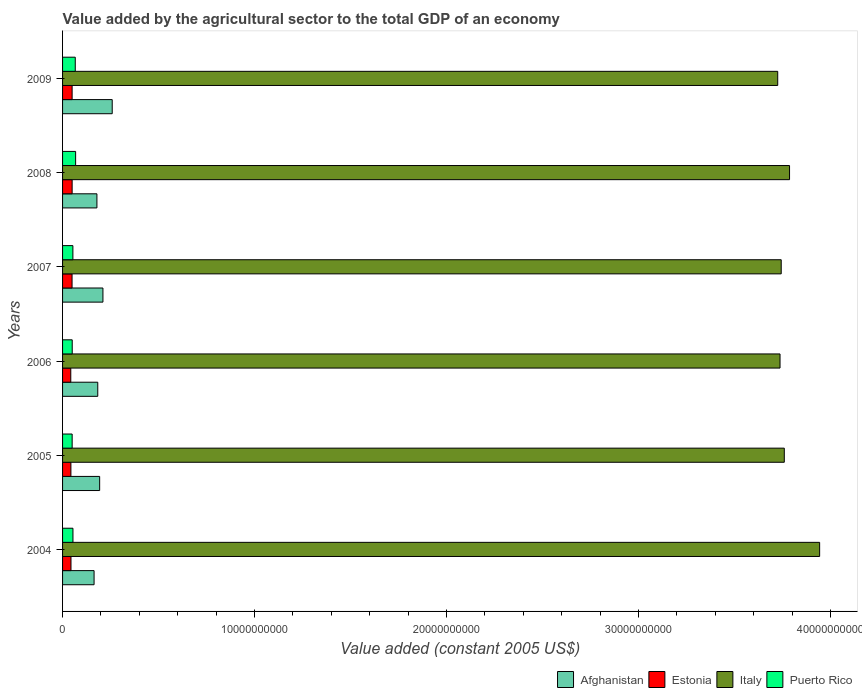How many different coloured bars are there?
Make the answer very short. 4. How many bars are there on the 2nd tick from the bottom?
Your answer should be very brief. 4. In how many cases, is the number of bars for a given year not equal to the number of legend labels?
Provide a succinct answer. 0. What is the value added by the agricultural sector in Afghanistan in 2008?
Keep it short and to the point. 1.79e+09. Across all years, what is the maximum value added by the agricultural sector in Afghanistan?
Ensure brevity in your answer.  2.59e+09. Across all years, what is the minimum value added by the agricultural sector in Afghanistan?
Offer a terse response. 1.64e+09. In which year was the value added by the agricultural sector in Afghanistan maximum?
Keep it short and to the point. 2009. What is the total value added by the agricultural sector in Puerto Rico in the graph?
Provide a succinct answer. 3.42e+09. What is the difference between the value added by the agricultural sector in Puerto Rico in 2008 and that in 2009?
Give a very brief answer. 1.86e+07. What is the difference between the value added by the agricultural sector in Italy in 2004 and the value added by the agricultural sector in Afghanistan in 2009?
Your answer should be compact. 3.68e+1. What is the average value added by the agricultural sector in Italy per year?
Offer a very short reply. 3.78e+1. In the year 2007, what is the difference between the value added by the agricultural sector in Puerto Rico and value added by the agricultural sector in Italy?
Make the answer very short. -3.69e+1. What is the ratio of the value added by the agricultural sector in Italy in 2007 to that in 2009?
Your answer should be very brief. 1. Is the value added by the agricultural sector in Estonia in 2007 less than that in 2009?
Offer a very short reply. Yes. Is the difference between the value added by the agricultural sector in Puerto Rico in 2005 and 2009 greater than the difference between the value added by the agricultural sector in Italy in 2005 and 2009?
Offer a terse response. No. What is the difference between the highest and the second highest value added by the agricultural sector in Estonia?
Your answer should be very brief. 1.08e+06. What is the difference between the highest and the lowest value added by the agricultural sector in Puerto Rico?
Your answer should be compact. 1.81e+08. In how many years, is the value added by the agricultural sector in Afghanistan greater than the average value added by the agricultural sector in Afghanistan taken over all years?
Provide a succinct answer. 2. Is the sum of the value added by the agricultural sector in Italy in 2006 and 2007 greater than the maximum value added by the agricultural sector in Afghanistan across all years?
Make the answer very short. Yes. What does the 4th bar from the top in 2007 represents?
Ensure brevity in your answer.  Afghanistan. What does the 1st bar from the bottom in 2007 represents?
Offer a very short reply. Afghanistan. Is it the case that in every year, the sum of the value added by the agricultural sector in Italy and value added by the agricultural sector in Estonia is greater than the value added by the agricultural sector in Afghanistan?
Your response must be concise. Yes. How many bars are there?
Make the answer very short. 24. What is the difference between two consecutive major ticks on the X-axis?
Provide a short and direct response. 1.00e+1. Does the graph contain grids?
Offer a very short reply. No. Where does the legend appear in the graph?
Your answer should be very brief. Bottom right. What is the title of the graph?
Keep it short and to the point. Value added by the agricultural sector to the total GDP of an economy. Does "Sweden" appear as one of the legend labels in the graph?
Give a very brief answer. No. What is the label or title of the X-axis?
Offer a very short reply. Value added (constant 2005 US$). What is the Value added (constant 2005 US$) of Afghanistan in 2004?
Give a very brief answer. 1.64e+09. What is the Value added (constant 2005 US$) of Estonia in 2004?
Provide a succinct answer. 4.38e+08. What is the Value added (constant 2005 US$) in Italy in 2004?
Offer a terse response. 3.94e+1. What is the Value added (constant 2005 US$) in Puerto Rico in 2004?
Offer a very short reply. 5.41e+08. What is the Value added (constant 2005 US$) in Afghanistan in 2005?
Give a very brief answer. 1.93e+09. What is the Value added (constant 2005 US$) in Estonia in 2005?
Keep it short and to the point. 4.34e+08. What is the Value added (constant 2005 US$) in Italy in 2005?
Offer a terse response. 3.76e+1. What is the Value added (constant 2005 US$) of Puerto Rico in 2005?
Keep it short and to the point. 4.99e+08. What is the Value added (constant 2005 US$) of Afghanistan in 2006?
Offer a terse response. 1.83e+09. What is the Value added (constant 2005 US$) in Estonia in 2006?
Your answer should be compact. 4.28e+08. What is the Value added (constant 2005 US$) in Italy in 2006?
Make the answer very short. 3.74e+1. What is the Value added (constant 2005 US$) in Puerto Rico in 2006?
Offer a terse response. 5.03e+08. What is the Value added (constant 2005 US$) in Afghanistan in 2007?
Make the answer very short. 2.10e+09. What is the Value added (constant 2005 US$) of Estonia in 2007?
Make the answer very short. 4.94e+08. What is the Value added (constant 2005 US$) in Italy in 2007?
Your answer should be compact. 3.74e+1. What is the Value added (constant 2005 US$) in Puerto Rico in 2007?
Offer a very short reply. 5.38e+08. What is the Value added (constant 2005 US$) of Afghanistan in 2008?
Make the answer very short. 1.79e+09. What is the Value added (constant 2005 US$) of Estonia in 2008?
Offer a terse response. 4.99e+08. What is the Value added (constant 2005 US$) of Italy in 2008?
Ensure brevity in your answer.  3.79e+1. What is the Value added (constant 2005 US$) in Puerto Rico in 2008?
Offer a terse response. 6.80e+08. What is the Value added (constant 2005 US$) of Afghanistan in 2009?
Provide a succinct answer. 2.59e+09. What is the Value added (constant 2005 US$) in Estonia in 2009?
Provide a short and direct response. 4.98e+08. What is the Value added (constant 2005 US$) in Italy in 2009?
Give a very brief answer. 3.72e+1. What is the Value added (constant 2005 US$) in Puerto Rico in 2009?
Offer a terse response. 6.62e+08. Across all years, what is the maximum Value added (constant 2005 US$) in Afghanistan?
Your answer should be compact. 2.59e+09. Across all years, what is the maximum Value added (constant 2005 US$) in Estonia?
Offer a very short reply. 4.99e+08. Across all years, what is the maximum Value added (constant 2005 US$) of Italy?
Provide a succinct answer. 3.94e+1. Across all years, what is the maximum Value added (constant 2005 US$) of Puerto Rico?
Offer a terse response. 6.80e+08. Across all years, what is the minimum Value added (constant 2005 US$) of Afghanistan?
Make the answer very short. 1.64e+09. Across all years, what is the minimum Value added (constant 2005 US$) of Estonia?
Offer a very short reply. 4.28e+08. Across all years, what is the minimum Value added (constant 2005 US$) in Italy?
Provide a short and direct response. 3.72e+1. Across all years, what is the minimum Value added (constant 2005 US$) in Puerto Rico?
Ensure brevity in your answer.  4.99e+08. What is the total Value added (constant 2005 US$) of Afghanistan in the graph?
Provide a succinct answer. 1.19e+1. What is the total Value added (constant 2005 US$) of Estonia in the graph?
Provide a short and direct response. 2.79e+09. What is the total Value added (constant 2005 US$) of Italy in the graph?
Make the answer very short. 2.27e+11. What is the total Value added (constant 2005 US$) of Puerto Rico in the graph?
Keep it short and to the point. 3.42e+09. What is the difference between the Value added (constant 2005 US$) in Afghanistan in 2004 and that in 2005?
Your response must be concise. -2.91e+08. What is the difference between the Value added (constant 2005 US$) in Estonia in 2004 and that in 2005?
Make the answer very short. 3.88e+06. What is the difference between the Value added (constant 2005 US$) in Italy in 2004 and that in 2005?
Offer a terse response. 1.84e+09. What is the difference between the Value added (constant 2005 US$) of Puerto Rico in 2004 and that in 2005?
Give a very brief answer. 4.16e+07. What is the difference between the Value added (constant 2005 US$) in Afghanistan in 2004 and that in 2006?
Give a very brief answer. -1.92e+08. What is the difference between the Value added (constant 2005 US$) of Estonia in 2004 and that in 2006?
Your answer should be compact. 9.87e+06. What is the difference between the Value added (constant 2005 US$) in Italy in 2004 and that in 2006?
Provide a short and direct response. 2.06e+09. What is the difference between the Value added (constant 2005 US$) of Puerto Rico in 2004 and that in 2006?
Your answer should be very brief. 3.84e+07. What is the difference between the Value added (constant 2005 US$) of Afghanistan in 2004 and that in 2007?
Your answer should be compact. -4.61e+08. What is the difference between the Value added (constant 2005 US$) of Estonia in 2004 and that in 2007?
Your answer should be compact. -5.62e+07. What is the difference between the Value added (constant 2005 US$) of Italy in 2004 and that in 2007?
Your response must be concise. 2.00e+09. What is the difference between the Value added (constant 2005 US$) of Puerto Rico in 2004 and that in 2007?
Offer a very short reply. 3.20e+06. What is the difference between the Value added (constant 2005 US$) in Afghanistan in 2004 and that in 2008?
Give a very brief answer. -1.48e+08. What is the difference between the Value added (constant 2005 US$) of Estonia in 2004 and that in 2008?
Keep it short and to the point. -6.05e+07. What is the difference between the Value added (constant 2005 US$) in Italy in 2004 and that in 2008?
Keep it short and to the point. 1.57e+09. What is the difference between the Value added (constant 2005 US$) of Puerto Rico in 2004 and that in 2008?
Keep it short and to the point. -1.40e+08. What is the difference between the Value added (constant 2005 US$) of Afghanistan in 2004 and that in 2009?
Ensure brevity in your answer.  -9.45e+08. What is the difference between the Value added (constant 2005 US$) in Estonia in 2004 and that in 2009?
Give a very brief answer. -5.94e+07. What is the difference between the Value added (constant 2005 US$) of Italy in 2004 and that in 2009?
Provide a succinct answer. 2.18e+09. What is the difference between the Value added (constant 2005 US$) in Puerto Rico in 2004 and that in 2009?
Your answer should be very brief. -1.21e+08. What is the difference between the Value added (constant 2005 US$) in Afghanistan in 2005 and that in 2006?
Provide a short and direct response. 9.87e+07. What is the difference between the Value added (constant 2005 US$) in Estonia in 2005 and that in 2006?
Provide a succinct answer. 5.99e+06. What is the difference between the Value added (constant 2005 US$) in Italy in 2005 and that in 2006?
Your response must be concise. 2.22e+08. What is the difference between the Value added (constant 2005 US$) in Puerto Rico in 2005 and that in 2006?
Your answer should be compact. -3.20e+06. What is the difference between the Value added (constant 2005 US$) in Afghanistan in 2005 and that in 2007?
Make the answer very short. -1.71e+08. What is the difference between the Value added (constant 2005 US$) of Estonia in 2005 and that in 2007?
Ensure brevity in your answer.  -6.01e+07. What is the difference between the Value added (constant 2005 US$) in Italy in 2005 and that in 2007?
Your answer should be compact. 1.60e+08. What is the difference between the Value added (constant 2005 US$) of Puerto Rico in 2005 and that in 2007?
Ensure brevity in your answer.  -3.84e+07. What is the difference between the Value added (constant 2005 US$) in Afghanistan in 2005 and that in 2008?
Your response must be concise. 1.43e+08. What is the difference between the Value added (constant 2005 US$) in Estonia in 2005 and that in 2008?
Provide a short and direct response. -6.44e+07. What is the difference between the Value added (constant 2005 US$) of Italy in 2005 and that in 2008?
Ensure brevity in your answer.  -2.73e+08. What is the difference between the Value added (constant 2005 US$) in Puerto Rico in 2005 and that in 2008?
Your answer should be very brief. -1.81e+08. What is the difference between the Value added (constant 2005 US$) in Afghanistan in 2005 and that in 2009?
Your answer should be compact. -6.54e+08. What is the difference between the Value added (constant 2005 US$) in Estonia in 2005 and that in 2009?
Offer a very short reply. -6.33e+07. What is the difference between the Value added (constant 2005 US$) in Italy in 2005 and that in 2009?
Give a very brief answer. 3.42e+08. What is the difference between the Value added (constant 2005 US$) in Puerto Rico in 2005 and that in 2009?
Your response must be concise. -1.63e+08. What is the difference between the Value added (constant 2005 US$) of Afghanistan in 2006 and that in 2007?
Your answer should be compact. -2.69e+08. What is the difference between the Value added (constant 2005 US$) in Estonia in 2006 and that in 2007?
Give a very brief answer. -6.61e+07. What is the difference between the Value added (constant 2005 US$) of Italy in 2006 and that in 2007?
Your answer should be compact. -6.16e+07. What is the difference between the Value added (constant 2005 US$) in Puerto Rico in 2006 and that in 2007?
Make the answer very short. -3.52e+07. What is the difference between the Value added (constant 2005 US$) of Afghanistan in 2006 and that in 2008?
Keep it short and to the point. 4.43e+07. What is the difference between the Value added (constant 2005 US$) in Estonia in 2006 and that in 2008?
Your answer should be very brief. -7.04e+07. What is the difference between the Value added (constant 2005 US$) in Italy in 2006 and that in 2008?
Keep it short and to the point. -4.95e+08. What is the difference between the Value added (constant 2005 US$) of Puerto Rico in 2006 and that in 2008?
Provide a short and direct response. -1.78e+08. What is the difference between the Value added (constant 2005 US$) of Afghanistan in 2006 and that in 2009?
Your answer should be very brief. -7.53e+08. What is the difference between the Value added (constant 2005 US$) in Estonia in 2006 and that in 2009?
Make the answer very short. -6.93e+07. What is the difference between the Value added (constant 2005 US$) of Italy in 2006 and that in 2009?
Your answer should be compact. 1.21e+08. What is the difference between the Value added (constant 2005 US$) of Puerto Rico in 2006 and that in 2009?
Your response must be concise. -1.59e+08. What is the difference between the Value added (constant 2005 US$) in Afghanistan in 2007 and that in 2008?
Offer a very short reply. 3.14e+08. What is the difference between the Value added (constant 2005 US$) in Estonia in 2007 and that in 2008?
Offer a terse response. -4.29e+06. What is the difference between the Value added (constant 2005 US$) of Italy in 2007 and that in 2008?
Provide a succinct answer. -4.34e+08. What is the difference between the Value added (constant 2005 US$) in Puerto Rico in 2007 and that in 2008?
Your answer should be very brief. -1.43e+08. What is the difference between the Value added (constant 2005 US$) in Afghanistan in 2007 and that in 2009?
Ensure brevity in your answer.  -4.84e+08. What is the difference between the Value added (constant 2005 US$) in Estonia in 2007 and that in 2009?
Keep it short and to the point. -3.21e+06. What is the difference between the Value added (constant 2005 US$) of Italy in 2007 and that in 2009?
Give a very brief answer. 1.82e+08. What is the difference between the Value added (constant 2005 US$) in Puerto Rico in 2007 and that in 2009?
Offer a very short reply. -1.24e+08. What is the difference between the Value added (constant 2005 US$) of Afghanistan in 2008 and that in 2009?
Provide a short and direct response. -7.97e+08. What is the difference between the Value added (constant 2005 US$) in Estonia in 2008 and that in 2009?
Your answer should be compact. 1.08e+06. What is the difference between the Value added (constant 2005 US$) of Italy in 2008 and that in 2009?
Provide a short and direct response. 6.16e+08. What is the difference between the Value added (constant 2005 US$) of Puerto Rico in 2008 and that in 2009?
Make the answer very short. 1.86e+07. What is the difference between the Value added (constant 2005 US$) in Afghanistan in 2004 and the Value added (constant 2005 US$) in Estonia in 2005?
Keep it short and to the point. 1.21e+09. What is the difference between the Value added (constant 2005 US$) of Afghanistan in 2004 and the Value added (constant 2005 US$) of Italy in 2005?
Provide a succinct answer. -3.59e+1. What is the difference between the Value added (constant 2005 US$) of Afghanistan in 2004 and the Value added (constant 2005 US$) of Puerto Rico in 2005?
Ensure brevity in your answer.  1.14e+09. What is the difference between the Value added (constant 2005 US$) in Estonia in 2004 and the Value added (constant 2005 US$) in Italy in 2005?
Your response must be concise. -3.72e+1. What is the difference between the Value added (constant 2005 US$) in Estonia in 2004 and the Value added (constant 2005 US$) in Puerto Rico in 2005?
Your answer should be compact. -6.12e+07. What is the difference between the Value added (constant 2005 US$) in Italy in 2004 and the Value added (constant 2005 US$) in Puerto Rico in 2005?
Your response must be concise. 3.89e+1. What is the difference between the Value added (constant 2005 US$) in Afghanistan in 2004 and the Value added (constant 2005 US$) in Estonia in 2006?
Ensure brevity in your answer.  1.21e+09. What is the difference between the Value added (constant 2005 US$) of Afghanistan in 2004 and the Value added (constant 2005 US$) of Italy in 2006?
Offer a terse response. -3.57e+1. What is the difference between the Value added (constant 2005 US$) of Afghanistan in 2004 and the Value added (constant 2005 US$) of Puerto Rico in 2006?
Your response must be concise. 1.14e+09. What is the difference between the Value added (constant 2005 US$) in Estonia in 2004 and the Value added (constant 2005 US$) in Italy in 2006?
Make the answer very short. -3.69e+1. What is the difference between the Value added (constant 2005 US$) in Estonia in 2004 and the Value added (constant 2005 US$) in Puerto Rico in 2006?
Provide a succinct answer. -6.44e+07. What is the difference between the Value added (constant 2005 US$) in Italy in 2004 and the Value added (constant 2005 US$) in Puerto Rico in 2006?
Ensure brevity in your answer.  3.89e+1. What is the difference between the Value added (constant 2005 US$) of Afghanistan in 2004 and the Value added (constant 2005 US$) of Estonia in 2007?
Make the answer very short. 1.15e+09. What is the difference between the Value added (constant 2005 US$) in Afghanistan in 2004 and the Value added (constant 2005 US$) in Italy in 2007?
Offer a very short reply. -3.58e+1. What is the difference between the Value added (constant 2005 US$) in Afghanistan in 2004 and the Value added (constant 2005 US$) in Puerto Rico in 2007?
Your response must be concise. 1.10e+09. What is the difference between the Value added (constant 2005 US$) of Estonia in 2004 and the Value added (constant 2005 US$) of Italy in 2007?
Give a very brief answer. -3.70e+1. What is the difference between the Value added (constant 2005 US$) in Estonia in 2004 and the Value added (constant 2005 US$) in Puerto Rico in 2007?
Give a very brief answer. -9.96e+07. What is the difference between the Value added (constant 2005 US$) of Italy in 2004 and the Value added (constant 2005 US$) of Puerto Rico in 2007?
Keep it short and to the point. 3.89e+1. What is the difference between the Value added (constant 2005 US$) of Afghanistan in 2004 and the Value added (constant 2005 US$) of Estonia in 2008?
Provide a succinct answer. 1.14e+09. What is the difference between the Value added (constant 2005 US$) in Afghanistan in 2004 and the Value added (constant 2005 US$) in Italy in 2008?
Provide a short and direct response. -3.62e+1. What is the difference between the Value added (constant 2005 US$) in Afghanistan in 2004 and the Value added (constant 2005 US$) in Puerto Rico in 2008?
Ensure brevity in your answer.  9.61e+08. What is the difference between the Value added (constant 2005 US$) in Estonia in 2004 and the Value added (constant 2005 US$) in Italy in 2008?
Your response must be concise. -3.74e+1. What is the difference between the Value added (constant 2005 US$) of Estonia in 2004 and the Value added (constant 2005 US$) of Puerto Rico in 2008?
Provide a short and direct response. -2.42e+08. What is the difference between the Value added (constant 2005 US$) in Italy in 2004 and the Value added (constant 2005 US$) in Puerto Rico in 2008?
Offer a very short reply. 3.88e+1. What is the difference between the Value added (constant 2005 US$) of Afghanistan in 2004 and the Value added (constant 2005 US$) of Estonia in 2009?
Your answer should be very brief. 1.14e+09. What is the difference between the Value added (constant 2005 US$) of Afghanistan in 2004 and the Value added (constant 2005 US$) of Italy in 2009?
Your response must be concise. -3.56e+1. What is the difference between the Value added (constant 2005 US$) in Afghanistan in 2004 and the Value added (constant 2005 US$) in Puerto Rico in 2009?
Offer a very short reply. 9.80e+08. What is the difference between the Value added (constant 2005 US$) in Estonia in 2004 and the Value added (constant 2005 US$) in Italy in 2009?
Ensure brevity in your answer.  -3.68e+1. What is the difference between the Value added (constant 2005 US$) in Estonia in 2004 and the Value added (constant 2005 US$) in Puerto Rico in 2009?
Offer a terse response. -2.24e+08. What is the difference between the Value added (constant 2005 US$) of Italy in 2004 and the Value added (constant 2005 US$) of Puerto Rico in 2009?
Give a very brief answer. 3.88e+1. What is the difference between the Value added (constant 2005 US$) in Afghanistan in 2005 and the Value added (constant 2005 US$) in Estonia in 2006?
Your answer should be very brief. 1.50e+09. What is the difference between the Value added (constant 2005 US$) in Afghanistan in 2005 and the Value added (constant 2005 US$) in Italy in 2006?
Keep it short and to the point. -3.54e+1. What is the difference between the Value added (constant 2005 US$) of Afghanistan in 2005 and the Value added (constant 2005 US$) of Puerto Rico in 2006?
Make the answer very short. 1.43e+09. What is the difference between the Value added (constant 2005 US$) in Estonia in 2005 and the Value added (constant 2005 US$) in Italy in 2006?
Your answer should be very brief. -3.69e+1. What is the difference between the Value added (constant 2005 US$) of Estonia in 2005 and the Value added (constant 2005 US$) of Puerto Rico in 2006?
Offer a terse response. -6.83e+07. What is the difference between the Value added (constant 2005 US$) in Italy in 2005 and the Value added (constant 2005 US$) in Puerto Rico in 2006?
Offer a very short reply. 3.71e+1. What is the difference between the Value added (constant 2005 US$) in Afghanistan in 2005 and the Value added (constant 2005 US$) in Estonia in 2007?
Your answer should be very brief. 1.44e+09. What is the difference between the Value added (constant 2005 US$) of Afghanistan in 2005 and the Value added (constant 2005 US$) of Italy in 2007?
Offer a terse response. -3.55e+1. What is the difference between the Value added (constant 2005 US$) in Afghanistan in 2005 and the Value added (constant 2005 US$) in Puerto Rico in 2007?
Make the answer very short. 1.39e+09. What is the difference between the Value added (constant 2005 US$) of Estonia in 2005 and the Value added (constant 2005 US$) of Italy in 2007?
Your answer should be compact. -3.70e+1. What is the difference between the Value added (constant 2005 US$) in Estonia in 2005 and the Value added (constant 2005 US$) in Puerto Rico in 2007?
Offer a very short reply. -1.03e+08. What is the difference between the Value added (constant 2005 US$) of Italy in 2005 and the Value added (constant 2005 US$) of Puerto Rico in 2007?
Keep it short and to the point. 3.71e+1. What is the difference between the Value added (constant 2005 US$) of Afghanistan in 2005 and the Value added (constant 2005 US$) of Estonia in 2008?
Your answer should be very brief. 1.43e+09. What is the difference between the Value added (constant 2005 US$) in Afghanistan in 2005 and the Value added (constant 2005 US$) in Italy in 2008?
Your answer should be very brief. -3.59e+1. What is the difference between the Value added (constant 2005 US$) in Afghanistan in 2005 and the Value added (constant 2005 US$) in Puerto Rico in 2008?
Offer a very short reply. 1.25e+09. What is the difference between the Value added (constant 2005 US$) in Estonia in 2005 and the Value added (constant 2005 US$) in Italy in 2008?
Your answer should be very brief. -3.74e+1. What is the difference between the Value added (constant 2005 US$) of Estonia in 2005 and the Value added (constant 2005 US$) of Puerto Rico in 2008?
Provide a succinct answer. -2.46e+08. What is the difference between the Value added (constant 2005 US$) in Italy in 2005 and the Value added (constant 2005 US$) in Puerto Rico in 2008?
Give a very brief answer. 3.69e+1. What is the difference between the Value added (constant 2005 US$) in Afghanistan in 2005 and the Value added (constant 2005 US$) in Estonia in 2009?
Make the answer very short. 1.43e+09. What is the difference between the Value added (constant 2005 US$) of Afghanistan in 2005 and the Value added (constant 2005 US$) of Italy in 2009?
Give a very brief answer. -3.53e+1. What is the difference between the Value added (constant 2005 US$) of Afghanistan in 2005 and the Value added (constant 2005 US$) of Puerto Rico in 2009?
Your answer should be very brief. 1.27e+09. What is the difference between the Value added (constant 2005 US$) of Estonia in 2005 and the Value added (constant 2005 US$) of Italy in 2009?
Offer a very short reply. -3.68e+1. What is the difference between the Value added (constant 2005 US$) in Estonia in 2005 and the Value added (constant 2005 US$) in Puerto Rico in 2009?
Provide a short and direct response. -2.28e+08. What is the difference between the Value added (constant 2005 US$) of Italy in 2005 and the Value added (constant 2005 US$) of Puerto Rico in 2009?
Your answer should be compact. 3.69e+1. What is the difference between the Value added (constant 2005 US$) of Afghanistan in 2006 and the Value added (constant 2005 US$) of Estonia in 2007?
Ensure brevity in your answer.  1.34e+09. What is the difference between the Value added (constant 2005 US$) of Afghanistan in 2006 and the Value added (constant 2005 US$) of Italy in 2007?
Your answer should be very brief. -3.56e+1. What is the difference between the Value added (constant 2005 US$) in Afghanistan in 2006 and the Value added (constant 2005 US$) in Puerto Rico in 2007?
Give a very brief answer. 1.30e+09. What is the difference between the Value added (constant 2005 US$) of Estonia in 2006 and the Value added (constant 2005 US$) of Italy in 2007?
Your response must be concise. -3.70e+1. What is the difference between the Value added (constant 2005 US$) in Estonia in 2006 and the Value added (constant 2005 US$) in Puerto Rico in 2007?
Your answer should be very brief. -1.09e+08. What is the difference between the Value added (constant 2005 US$) of Italy in 2006 and the Value added (constant 2005 US$) of Puerto Rico in 2007?
Your response must be concise. 3.68e+1. What is the difference between the Value added (constant 2005 US$) in Afghanistan in 2006 and the Value added (constant 2005 US$) in Estonia in 2008?
Provide a succinct answer. 1.33e+09. What is the difference between the Value added (constant 2005 US$) in Afghanistan in 2006 and the Value added (constant 2005 US$) in Italy in 2008?
Keep it short and to the point. -3.60e+1. What is the difference between the Value added (constant 2005 US$) in Afghanistan in 2006 and the Value added (constant 2005 US$) in Puerto Rico in 2008?
Your answer should be compact. 1.15e+09. What is the difference between the Value added (constant 2005 US$) of Estonia in 2006 and the Value added (constant 2005 US$) of Italy in 2008?
Make the answer very short. -3.74e+1. What is the difference between the Value added (constant 2005 US$) in Estonia in 2006 and the Value added (constant 2005 US$) in Puerto Rico in 2008?
Your response must be concise. -2.52e+08. What is the difference between the Value added (constant 2005 US$) of Italy in 2006 and the Value added (constant 2005 US$) of Puerto Rico in 2008?
Keep it short and to the point. 3.67e+1. What is the difference between the Value added (constant 2005 US$) of Afghanistan in 2006 and the Value added (constant 2005 US$) of Estonia in 2009?
Offer a very short reply. 1.34e+09. What is the difference between the Value added (constant 2005 US$) of Afghanistan in 2006 and the Value added (constant 2005 US$) of Italy in 2009?
Provide a short and direct response. -3.54e+1. What is the difference between the Value added (constant 2005 US$) of Afghanistan in 2006 and the Value added (constant 2005 US$) of Puerto Rico in 2009?
Offer a terse response. 1.17e+09. What is the difference between the Value added (constant 2005 US$) in Estonia in 2006 and the Value added (constant 2005 US$) in Italy in 2009?
Your answer should be very brief. -3.68e+1. What is the difference between the Value added (constant 2005 US$) of Estonia in 2006 and the Value added (constant 2005 US$) of Puerto Rico in 2009?
Give a very brief answer. -2.34e+08. What is the difference between the Value added (constant 2005 US$) of Italy in 2006 and the Value added (constant 2005 US$) of Puerto Rico in 2009?
Provide a short and direct response. 3.67e+1. What is the difference between the Value added (constant 2005 US$) in Afghanistan in 2007 and the Value added (constant 2005 US$) in Estonia in 2008?
Provide a succinct answer. 1.60e+09. What is the difference between the Value added (constant 2005 US$) of Afghanistan in 2007 and the Value added (constant 2005 US$) of Italy in 2008?
Offer a very short reply. -3.58e+1. What is the difference between the Value added (constant 2005 US$) of Afghanistan in 2007 and the Value added (constant 2005 US$) of Puerto Rico in 2008?
Provide a short and direct response. 1.42e+09. What is the difference between the Value added (constant 2005 US$) of Estonia in 2007 and the Value added (constant 2005 US$) of Italy in 2008?
Your response must be concise. -3.74e+1. What is the difference between the Value added (constant 2005 US$) of Estonia in 2007 and the Value added (constant 2005 US$) of Puerto Rico in 2008?
Provide a succinct answer. -1.86e+08. What is the difference between the Value added (constant 2005 US$) in Italy in 2007 and the Value added (constant 2005 US$) in Puerto Rico in 2008?
Provide a succinct answer. 3.67e+1. What is the difference between the Value added (constant 2005 US$) of Afghanistan in 2007 and the Value added (constant 2005 US$) of Estonia in 2009?
Give a very brief answer. 1.61e+09. What is the difference between the Value added (constant 2005 US$) of Afghanistan in 2007 and the Value added (constant 2005 US$) of Italy in 2009?
Your answer should be compact. -3.51e+1. What is the difference between the Value added (constant 2005 US$) of Afghanistan in 2007 and the Value added (constant 2005 US$) of Puerto Rico in 2009?
Offer a very short reply. 1.44e+09. What is the difference between the Value added (constant 2005 US$) of Estonia in 2007 and the Value added (constant 2005 US$) of Italy in 2009?
Provide a short and direct response. -3.68e+1. What is the difference between the Value added (constant 2005 US$) in Estonia in 2007 and the Value added (constant 2005 US$) in Puerto Rico in 2009?
Keep it short and to the point. -1.68e+08. What is the difference between the Value added (constant 2005 US$) of Italy in 2007 and the Value added (constant 2005 US$) of Puerto Rico in 2009?
Provide a short and direct response. 3.68e+1. What is the difference between the Value added (constant 2005 US$) of Afghanistan in 2008 and the Value added (constant 2005 US$) of Estonia in 2009?
Provide a short and direct response. 1.29e+09. What is the difference between the Value added (constant 2005 US$) in Afghanistan in 2008 and the Value added (constant 2005 US$) in Italy in 2009?
Your answer should be very brief. -3.55e+1. What is the difference between the Value added (constant 2005 US$) in Afghanistan in 2008 and the Value added (constant 2005 US$) in Puerto Rico in 2009?
Make the answer very short. 1.13e+09. What is the difference between the Value added (constant 2005 US$) of Estonia in 2008 and the Value added (constant 2005 US$) of Italy in 2009?
Your response must be concise. -3.67e+1. What is the difference between the Value added (constant 2005 US$) of Estonia in 2008 and the Value added (constant 2005 US$) of Puerto Rico in 2009?
Make the answer very short. -1.63e+08. What is the difference between the Value added (constant 2005 US$) in Italy in 2008 and the Value added (constant 2005 US$) in Puerto Rico in 2009?
Keep it short and to the point. 3.72e+1. What is the average Value added (constant 2005 US$) of Afghanistan per year?
Ensure brevity in your answer.  1.98e+09. What is the average Value added (constant 2005 US$) in Estonia per year?
Give a very brief answer. 4.65e+08. What is the average Value added (constant 2005 US$) in Italy per year?
Offer a very short reply. 3.78e+1. What is the average Value added (constant 2005 US$) in Puerto Rico per year?
Ensure brevity in your answer.  5.70e+08. In the year 2004, what is the difference between the Value added (constant 2005 US$) of Afghanistan and Value added (constant 2005 US$) of Estonia?
Provide a succinct answer. 1.20e+09. In the year 2004, what is the difference between the Value added (constant 2005 US$) of Afghanistan and Value added (constant 2005 US$) of Italy?
Offer a terse response. -3.78e+1. In the year 2004, what is the difference between the Value added (constant 2005 US$) of Afghanistan and Value added (constant 2005 US$) of Puerto Rico?
Offer a very short reply. 1.10e+09. In the year 2004, what is the difference between the Value added (constant 2005 US$) of Estonia and Value added (constant 2005 US$) of Italy?
Make the answer very short. -3.90e+1. In the year 2004, what is the difference between the Value added (constant 2005 US$) in Estonia and Value added (constant 2005 US$) in Puerto Rico?
Your answer should be very brief. -1.03e+08. In the year 2004, what is the difference between the Value added (constant 2005 US$) of Italy and Value added (constant 2005 US$) of Puerto Rico?
Provide a short and direct response. 3.89e+1. In the year 2005, what is the difference between the Value added (constant 2005 US$) of Afghanistan and Value added (constant 2005 US$) of Estonia?
Offer a terse response. 1.50e+09. In the year 2005, what is the difference between the Value added (constant 2005 US$) of Afghanistan and Value added (constant 2005 US$) of Italy?
Make the answer very short. -3.57e+1. In the year 2005, what is the difference between the Value added (constant 2005 US$) of Afghanistan and Value added (constant 2005 US$) of Puerto Rico?
Provide a short and direct response. 1.43e+09. In the year 2005, what is the difference between the Value added (constant 2005 US$) of Estonia and Value added (constant 2005 US$) of Italy?
Offer a very short reply. -3.72e+1. In the year 2005, what is the difference between the Value added (constant 2005 US$) in Estonia and Value added (constant 2005 US$) in Puerto Rico?
Give a very brief answer. -6.51e+07. In the year 2005, what is the difference between the Value added (constant 2005 US$) of Italy and Value added (constant 2005 US$) of Puerto Rico?
Keep it short and to the point. 3.71e+1. In the year 2006, what is the difference between the Value added (constant 2005 US$) of Afghanistan and Value added (constant 2005 US$) of Estonia?
Offer a terse response. 1.41e+09. In the year 2006, what is the difference between the Value added (constant 2005 US$) in Afghanistan and Value added (constant 2005 US$) in Italy?
Your response must be concise. -3.55e+1. In the year 2006, what is the difference between the Value added (constant 2005 US$) in Afghanistan and Value added (constant 2005 US$) in Puerto Rico?
Ensure brevity in your answer.  1.33e+09. In the year 2006, what is the difference between the Value added (constant 2005 US$) of Estonia and Value added (constant 2005 US$) of Italy?
Offer a very short reply. -3.69e+1. In the year 2006, what is the difference between the Value added (constant 2005 US$) of Estonia and Value added (constant 2005 US$) of Puerto Rico?
Ensure brevity in your answer.  -7.42e+07. In the year 2006, what is the difference between the Value added (constant 2005 US$) in Italy and Value added (constant 2005 US$) in Puerto Rico?
Give a very brief answer. 3.69e+1. In the year 2007, what is the difference between the Value added (constant 2005 US$) of Afghanistan and Value added (constant 2005 US$) of Estonia?
Ensure brevity in your answer.  1.61e+09. In the year 2007, what is the difference between the Value added (constant 2005 US$) in Afghanistan and Value added (constant 2005 US$) in Italy?
Ensure brevity in your answer.  -3.53e+1. In the year 2007, what is the difference between the Value added (constant 2005 US$) in Afghanistan and Value added (constant 2005 US$) in Puerto Rico?
Make the answer very short. 1.56e+09. In the year 2007, what is the difference between the Value added (constant 2005 US$) of Estonia and Value added (constant 2005 US$) of Italy?
Give a very brief answer. -3.69e+1. In the year 2007, what is the difference between the Value added (constant 2005 US$) of Estonia and Value added (constant 2005 US$) of Puerto Rico?
Provide a short and direct response. -4.34e+07. In the year 2007, what is the difference between the Value added (constant 2005 US$) in Italy and Value added (constant 2005 US$) in Puerto Rico?
Keep it short and to the point. 3.69e+1. In the year 2008, what is the difference between the Value added (constant 2005 US$) in Afghanistan and Value added (constant 2005 US$) in Estonia?
Your answer should be very brief. 1.29e+09. In the year 2008, what is the difference between the Value added (constant 2005 US$) of Afghanistan and Value added (constant 2005 US$) of Italy?
Keep it short and to the point. -3.61e+1. In the year 2008, what is the difference between the Value added (constant 2005 US$) of Afghanistan and Value added (constant 2005 US$) of Puerto Rico?
Make the answer very short. 1.11e+09. In the year 2008, what is the difference between the Value added (constant 2005 US$) of Estonia and Value added (constant 2005 US$) of Italy?
Your answer should be compact. -3.74e+1. In the year 2008, what is the difference between the Value added (constant 2005 US$) in Estonia and Value added (constant 2005 US$) in Puerto Rico?
Offer a terse response. -1.82e+08. In the year 2008, what is the difference between the Value added (constant 2005 US$) in Italy and Value added (constant 2005 US$) in Puerto Rico?
Make the answer very short. 3.72e+1. In the year 2009, what is the difference between the Value added (constant 2005 US$) in Afghanistan and Value added (constant 2005 US$) in Estonia?
Your response must be concise. 2.09e+09. In the year 2009, what is the difference between the Value added (constant 2005 US$) of Afghanistan and Value added (constant 2005 US$) of Italy?
Your response must be concise. -3.47e+1. In the year 2009, what is the difference between the Value added (constant 2005 US$) of Afghanistan and Value added (constant 2005 US$) of Puerto Rico?
Your response must be concise. 1.92e+09. In the year 2009, what is the difference between the Value added (constant 2005 US$) of Estonia and Value added (constant 2005 US$) of Italy?
Your response must be concise. -3.68e+1. In the year 2009, what is the difference between the Value added (constant 2005 US$) in Estonia and Value added (constant 2005 US$) in Puerto Rico?
Offer a very short reply. -1.64e+08. In the year 2009, what is the difference between the Value added (constant 2005 US$) of Italy and Value added (constant 2005 US$) of Puerto Rico?
Your answer should be very brief. 3.66e+1. What is the ratio of the Value added (constant 2005 US$) in Afghanistan in 2004 to that in 2005?
Offer a terse response. 0.85. What is the ratio of the Value added (constant 2005 US$) of Estonia in 2004 to that in 2005?
Your answer should be compact. 1.01. What is the ratio of the Value added (constant 2005 US$) of Italy in 2004 to that in 2005?
Offer a very short reply. 1.05. What is the ratio of the Value added (constant 2005 US$) in Afghanistan in 2004 to that in 2006?
Your response must be concise. 0.9. What is the ratio of the Value added (constant 2005 US$) of Italy in 2004 to that in 2006?
Make the answer very short. 1.06. What is the ratio of the Value added (constant 2005 US$) in Puerto Rico in 2004 to that in 2006?
Provide a succinct answer. 1.08. What is the ratio of the Value added (constant 2005 US$) in Afghanistan in 2004 to that in 2007?
Make the answer very short. 0.78. What is the ratio of the Value added (constant 2005 US$) of Estonia in 2004 to that in 2007?
Provide a succinct answer. 0.89. What is the ratio of the Value added (constant 2005 US$) in Italy in 2004 to that in 2007?
Offer a terse response. 1.05. What is the ratio of the Value added (constant 2005 US$) in Puerto Rico in 2004 to that in 2007?
Provide a short and direct response. 1.01. What is the ratio of the Value added (constant 2005 US$) in Afghanistan in 2004 to that in 2008?
Your answer should be compact. 0.92. What is the ratio of the Value added (constant 2005 US$) in Estonia in 2004 to that in 2008?
Make the answer very short. 0.88. What is the ratio of the Value added (constant 2005 US$) of Italy in 2004 to that in 2008?
Your answer should be very brief. 1.04. What is the ratio of the Value added (constant 2005 US$) in Puerto Rico in 2004 to that in 2008?
Offer a terse response. 0.79. What is the ratio of the Value added (constant 2005 US$) of Afghanistan in 2004 to that in 2009?
Ensure brevity in your answer.  0.63. What is the ratio of the Value added (constant 2005 US$) in Estonia in 2004 to that in 2009?
Offer a very short reply. 0.88. What is the ratio of the Value added (constant 2005 US$) in Italy in 2004 to that in 2009?
Provide a succinct answer. 1.06. What is the ratio of the Value added (constant 2005 US$) in Puerto Rico in 2004 to that in 2009?
Your answer should be compact. 0.82. What is the ratio of the Value added (constant 2005 US$) in Afghanistan in 2005 to that in 2006?
Ensure brevity in your answer.  1.05. What is the ratio of the Value added (constant 2005 US$) of Estonia in 2005 to that in 2006?
Make the answer very short. 1.01. What is the ratio of the Value added (constant 2005 US$) in Italy in 2005 to that in 2006?
Offer a terse response. 1.01. What is the ratio of the Value added (constant 2005 US$) of Puerto Rico in 2005 to that in 2006?
Give a very brief answer. 0.99. What is the ratio of the Value added (constant 2005 US$) in Afghanistan in 2005 to that in 2007?
Ensure brevity in your answer.  0.92. What is the ratio of the Value added (constant 2005 US$) of Estonia in 2005 to that in 2007?
Ensure brevity in your answer.  0.88. What is the ratio of the Value added (constant 2005 US$) of Puerto Rico in 2005 to that in 2007?
Provide a succinct answer. 0.93. What is the ratio of the Value added (constant 2005 US$) of Afghanistan in 2005 to that in 2008?
Provide a short and direct response. 1.08. What is the ratio of the Value added (constant 2005 US$) in Estonia in 2005 to that in 2008?
Make the answer very short. 0.87. What is the ratio of the Value added (constant 2005 US$) of Puerto Rico in 2005 to that in 2008?
Your response must be concise. 0.73. What is the ratio of the Value added (constant 2005 US$) of Afghanistan in 2005 to that in 2009?
Ensure brevity in your answer.  0.75. What is the ratio of the Value added (constant 2005 US$) in Estonia in 2005 to that in 2009?
Make the answer very short. 0.87. What is the ratio of the Value added (constant 2005 US$) in Italy in 2005 to that in 2009?
Ensure brevity in your answer.  1.01. What is the ratio of the Value added (constant 2005 US$) of Puerto Rico in 2005 to that in 2009?
Your answer should be compact. 0.75. What is the ratio of the Value added (constant 2005 US$) in Afghanistan in 2006 to that in 2007?
Provide a short and direct response. 0.87. What is the ratio of the Value added (constant 2005 US$) in Estonia in 2006 to that in 2007?
Give a very brief answer. 0.87. What is the ratio of the Value added (constant 2005 US$) of Italy in 2006 to that in 2007?
Make the answer very short. 1. What is the ratio of the Value added (constant 2005 US$) in Puerto Rico in 2006 to that in 2007?
Offer a very short reply. 0.93. What is the ratio of the Value added (constant 2005 US$) in Afghanistan in 2006 to that in 2008?
Make the answer very short. 1.02. What is the ratio of the Value added (constant 2005 US$) in Estonia in 2006 to that in 2008?
Provide a succinct answer. 0.86. What is the ratio of the Value added (constant 2005 US$) in Italy in 2006 to that in 2008?
Provide a succinct answer. 0.99. What is the ratio of the Value added (constant 2005 US$) in Puerto Rico in 2006 to that in 2008?
Provide a succinct answer. 0.74. What is the ratio of the Value added (constant 2005 US$) in Afghanistan in 2006 to that in 2009?
Offer a very short reply. 0.71. What is the ratio of the Value added (constant 2005 US$) in Estonia in 2006 to that in 2009?
Your response must be concise. 0.86. What is the ratio of the Value added (constant 2005 US$) in Puerto Rico in 2006 to that in 2009?
Ensure brevity in your answer.  0.76. What is the ratio of the Value added (constant 2005 US$) of Afghanistan in 2007 to that in 2008?
Ensure brevity in your answer.  1.18. What is the ratio of the Value added (constant 2005 US$) in Estonia in 2007 to that in 2008?
Offer a terse response. 0.99. What is the ratio of the Value added (constant 2005 US$) of Italy in 2007 to that in 2008?
Your answer should be compact. 0.99. What is the ratio of the Value added (constant 2005 US$) in Puerto Rico in 2007 to that in 2008?
Your answer should be very brief. 0.79. What is the ratio of the Value added (constant 2005 US$) of Afghanistan in 2007 to that in 2009?
Offer a terse response. 0.81. What is the ratio of the Value added (constant 2005 US$) in Puerto Rico in 2007 to that in 2009?
Offer a very short reply. 0.81. What is the ratio of the Value added (constant 2005 US$) in Afghanistan in 2008 to that in 2009?
Give a very brief answer. 0.69. What is the ratio of the Value added (constant 2005 US$) in Estonia in 2008 to that in 2009?
Keep it short and to the point. 1. What is the ratio of the Value added (constant 2005 US$) in Italy in 2008 to that in 2009?
Make the answer very short. 1.02. What is the ratio of the Value added (constant 2005 US$) in Puerto Rico in 2008 to that in 2009?
Your answer should be very brief. 1.03. What is the difference between the highest and the second highest Value added (constant 2005 US$) in Afghanistan?
Your response must be concise. 4.84e+08. What is the difference between the highest and the second highest Value added (constant 2005 US$) of Estonia?
Keep it short and to the point. 1.08e+06. What is the difference between the highest and the second highest Value added (constant 2005 US$) in Italy?
Your answer should be very brief. 1.57e+09. What is the difference between the highest and the second highest Value added (constant 2005 US$) in Puerto Rico?
Make the answer very short. 1.86e+07. What is the difference between the highest and the lowest Value added (constant 2005 US$) of Afghanistan?
Your answer should be very brief. 9.45e+08. What is the difference between the highest and the lowest Value added (constant 2005 US$) in Estonia?
Offer a terse response. 7.04e+07. What is the difference between the highest and the lowest Value added (constant 2005 US$) in Italy?
Your response must be concise. 2.18e+09. What is the difference between the highest and the lowest Value added (constant 2005 US$) in Puerto Rico?
Provide a short and direct response. 1.81e+08. 